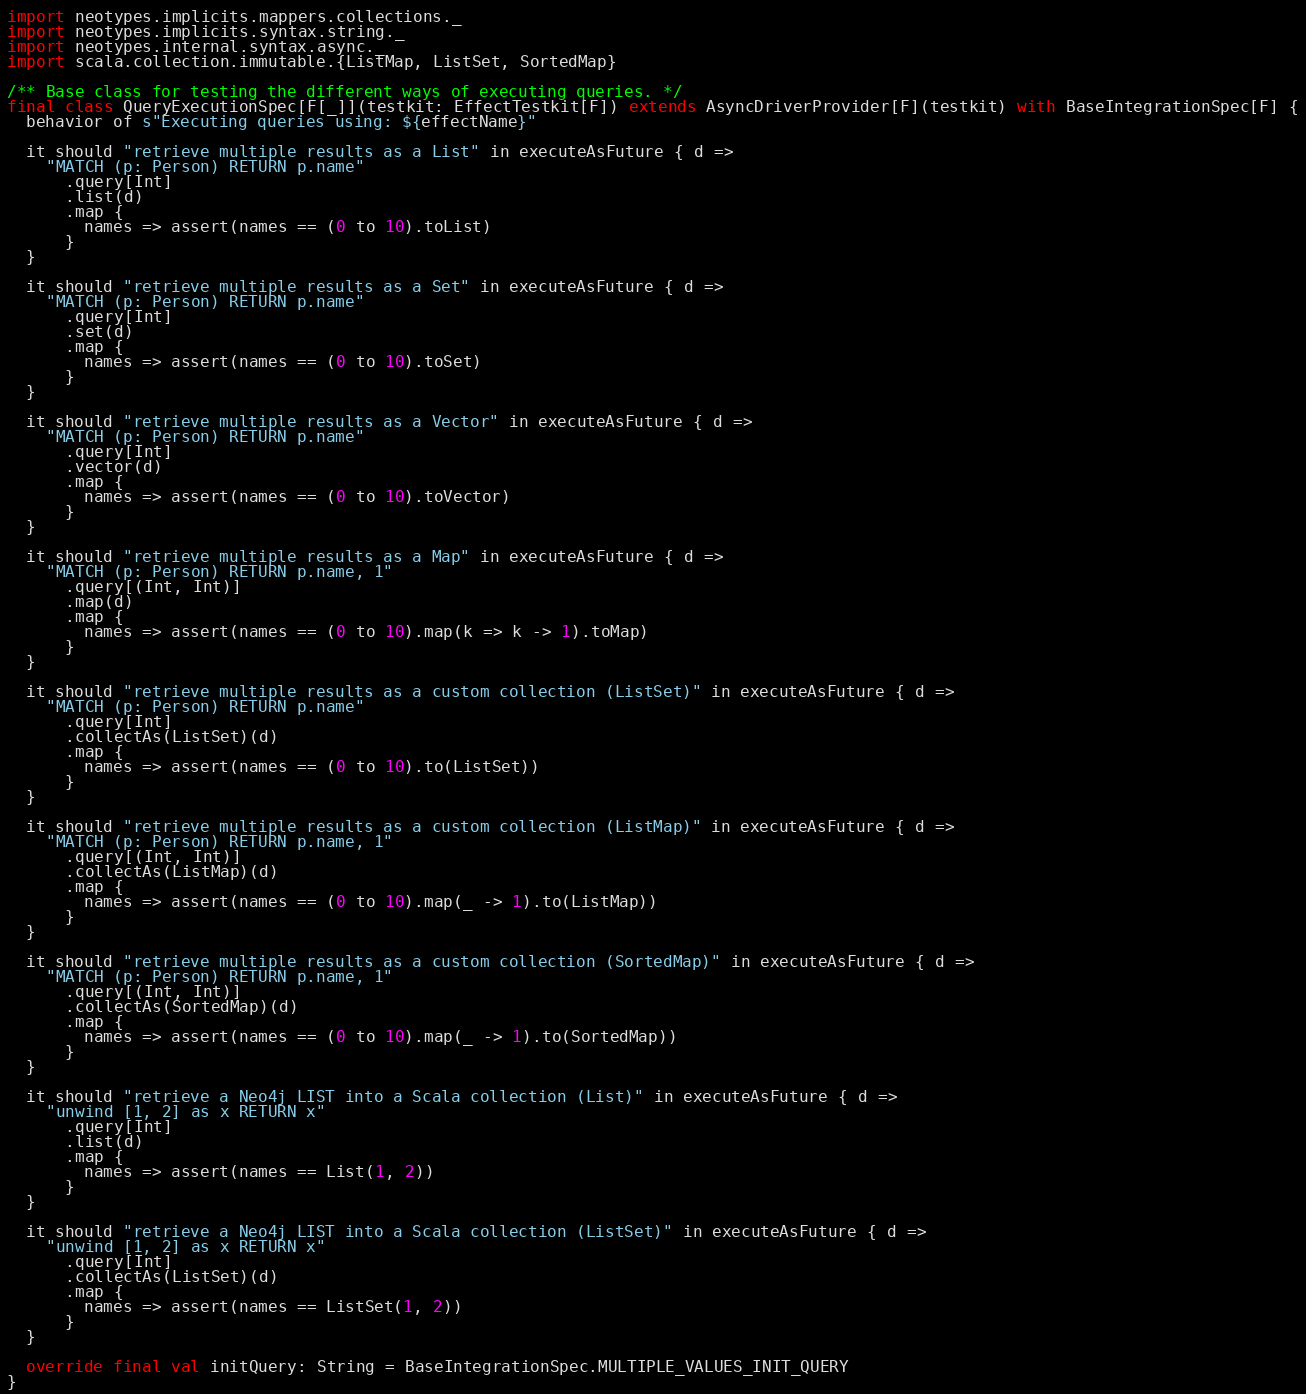Convert code to text. <code><loc_0><loc_0><loc_500><loc_500><_Scala_>import neotypes.implicits.mappers.collections._
import neotypes.implicits.syntax.string._
import neotypes.internal.syntax.async._
import scala.collection.immutable.{ListMap, ListSet, SortedMap}

/** Base class for testing the different ways of executing queries. */
final class QueryExecutionSpec[F[_]](testkit: EffectTestkit[F]) extends AsyncDriverProvider[F](testkit) with BaseIntegrationSpec[F] {
  behavior of s"Executing queries using: ${effectName}"

  it should "retrieve multiple results as a List" in executeAsFuture { d =>
    "MATCH (p: Person) RETURN p.name"
      .query[Int]
      .list(d)
      .map {
        names => assert(names == (0 to 10).toList)
      }
  }

  it should "retrieve multiple results as a Set" in executeAsFuture { d =>
    "MATCH (p: Person) RETURN p.name"
      .query[Int]
      .set(d)
      .map {
        names => assert(names == (0 to 10).toSet)
      }
  }

  it should "retrieve multiple results as a Vector" in executeAsFuture { d =>
    "MATCH (p: Person) RETURN p.name"
      .query[Int]
      .vector(d)
      .map {
        names => assert(names == (0 to 10).toVector)
      }
  }

  it should "retrieve multiple results as a Map" in executeAsFuture { d =>
    "MATCH (p: Person) RETURN p.name, 1"
      .query[(Int, Int)]
      .map(d)
      .map {
        names => assert(names == (0 to 10).map(k => k -> 1).toMap)
      }
  }

  it should "retrieve multiple results as a custom collection (ListSet)" in executeAsFuture { d =>
    "MATCH (p: Person) RETURN p.name"
      .query[Int]
      .collectAs(ListSet)(d)
      .map {
        names => assert(names == (0 to 10).to(ListSet))
      }
  }

  it should "retrieve multiple results as a custom collection (ListMap)" in executeAsFuture { d =>
    "MATCH (p: Person) RETURN p.name, 1"
      .query[(Int, Int)]
      .collectAs(ListMap)(d)
      .map {
        names => assert(names == (0 to 10).map(_ -> 1).to(ListMap))
      }
  }

  it should "retrieve multiple results as a custom collection (SortedMap)" in executeAsFuture { d =>
    "MATCH (p: Person) RETURN p.name, 1"
      .query[(Int, Int)]
      .collectAs(SortedMap)(d)
      .map {
        names => assert(names == (0 to 10).map(_ -> 1).to(SortedMap))
      }
  }

  it should "retrieve a Neo4j LIST into a Scala collection (List)" in executeAsFuture { d =>
    "unwind [1, 2] as x RETURN x"
      .query[Int]
      .list(d)
      .map {
        names => assert(names == List(1, 2))
      }
  }

  it should "retrieve a Neo4j LIST into a Scala collection (ListSet)" in executeAsFuture { d =>
    "unwind [1, 2] as x RETURN x"
      .query[Int]
      .collectAs(ListSet)(d)
      .map {
        names => assert(names == ListSet(1, 2))
      }
  }

  override final val initQuery: String = BaseIntegrationSpec.MULTIPLE_VALUES_INIT_QUERY
}
</code> 